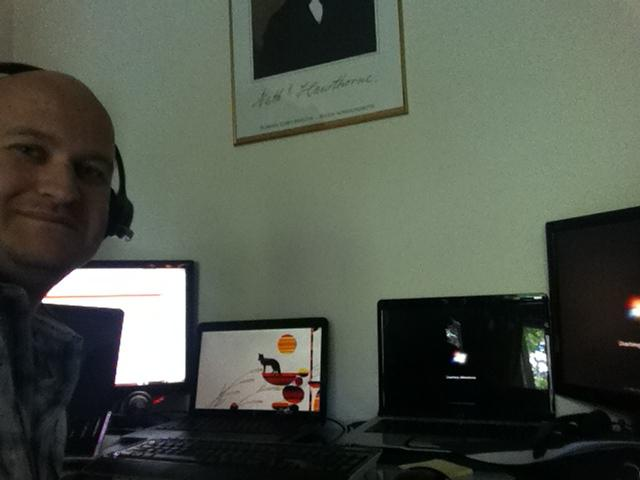What was installed on both the computers?

Choices:
A) windows
B) solaris
C) linux
D) osx windows 